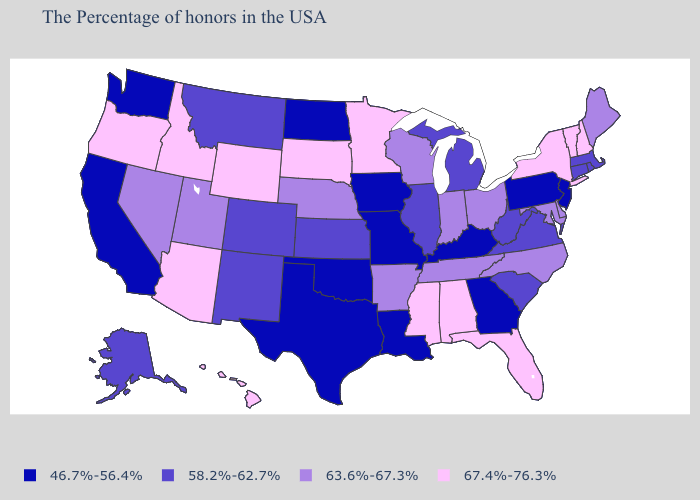Among the states that border California , which have the highest value?
Give a very brief answer. Arizona, Oregon. Among the states that border Vermont , does New York have the lowest value?
Keep it brief. No. Name the states that have a value in the range 67.4%-76.3%?
Write a very short answer. New Hampshire, Vermont, New York, Florida, Alabama, Mississippi, Minnesota, South Dakota, Wyoming, Arizona, Idaho, Oregon, Hawaii. What is the value of Nevada?
Answer briefly. 63.6%-67.3%. Name the states that have a value in the range 46.7%-56.4%?
Concise answer only. New Jersey, Pennsylvania, Georgia, Kentucky, Louisiana, Missouri, Iowa, Oklahoma, Texas, North Dakota, California, Washington. Which states have the lowest value in the USA?
Answer briefly. New Jersey, Pennsylvania, Georgia, Kentucky, Louisiana, Missouri, Iowa, Oklahoma, Texas, North Dakota, California, Washington. Which states have the lowest value in the USA?
Quick response, please. New Jersey, Pennsylvania, Georgia, Kentucky, Louisiana, Missouri, Iowa, Oklahoma, Texas, North Dakota, California, Washington. Does Georgia have a higher value than Arkansas?
Quick response, please. No. Among the states that border Iowa , does Wisconsin have the lowest value?
Keep it brief. No. Is the legend a continuous bar?
Short answer required. No. Which states have the highest value in the USA?
Give a very brief answer. New Hampshire, Vermont, New York, Florida, Alabama, Mississippi, Minnesota, South Dakota, Wyoming, Arizona, Idaho, Oregon, Hawaii. Does Arkansas have the lowest value in the USA?
Be succinct. No. What is the value of Nevada?
Quick response, please. 63.6%-67.3%. Which states have the lowest value in the USA?
Give a very brief answer. New Jersey, Pennsylvania, Georgia, Kentucky, Louisiana, Missouri, Iowa, Oklahoma, Texas, North Dakota, California, Washington. Name the states that have a value in the range 67.4%-76.3%?
Quick response, please. New Hampshire, Vermont, New York, Florida, Alabama, Mississippi, Minnesota, South Dakota, Wyoming, Arizona, Idaho, Oregon, Hawaii. 